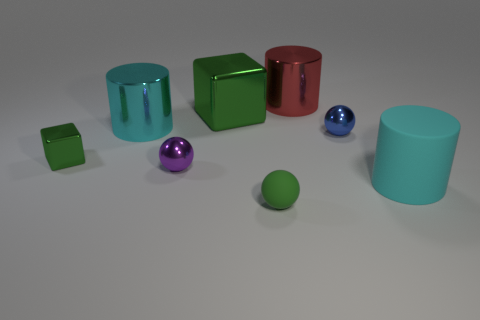There is a cylinder on the left side of the small purple thing; is its size the same as the ball in front of the big rubber cylinder?
Ensure brevity in your answer.  No. Is there a small cyan block made of the same material as the blue ball?
Your answer should be compact. No. What number of objects are cylinders that are to the right of the small blue shiny sphere or metal balls?
Give a very brief answer. 3. Does the cyan cylinder that is on the right side of the small matte thing have the same material as the purple thing?
Give a very brief answer. No. Is the large rubber object the same shape as the red object?
Provide a succinct answer. Yes. There is a shiny cylinder that is to the left of the large red metal cylinder; what number of small shiny objects are left of it?
Offer a terse response. 1. There is a green object that is the same shape as the purple shiny thing; what material is it?
Make the answer very short. Rubber. Is the color of the cube that is in front of the small blue sphere the same as the large shiny cube?
Your response must be concise. Yes. Is the small purple sphere made of the same material as the cyan thing that is on the right side of the big green thing?
Your response must be concise. No. What is the shape of the tiny metallic object to the right of the red thing?
Ensure brevity in your answer.  Sphere. 